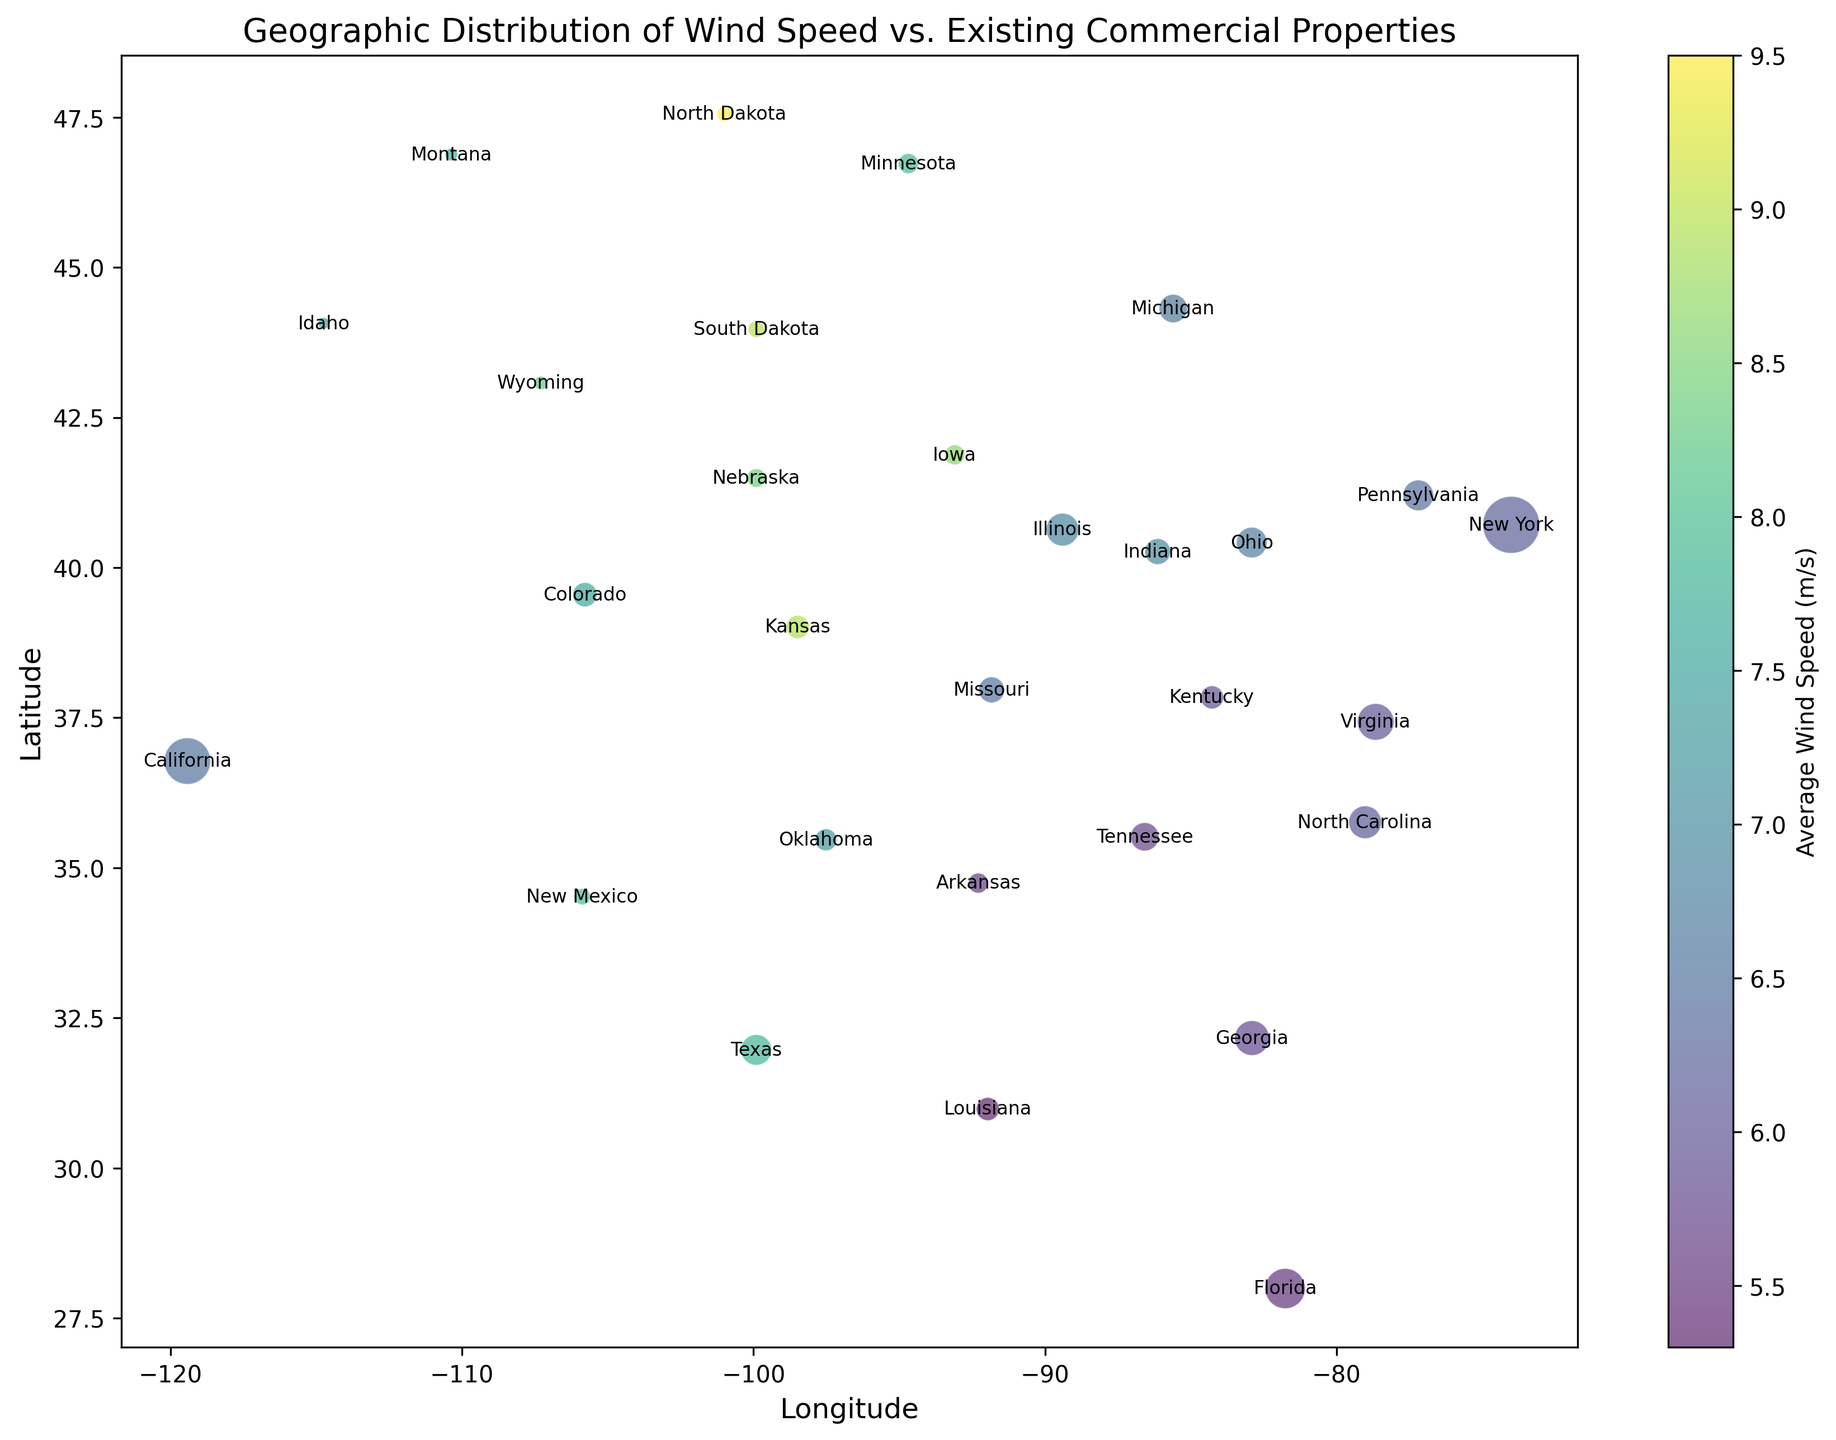Which location has the highest average wind speed? By looking at the color and name annotations in the figure, the location with the darkest shade indicating the highest wind speed is North Dakota.
Answer: North Dakota Which location has the largest number of commercial properties? The largest bubble on the plot represents New York, indicating it has the highest number of commercial properties.
Answer: New York What is the average wind speed of California and Florida combined? The average wind speed for California is 6.5 m/s and for Florida is 5.5 m/s. The combined average is (6.5 + 5.5) / 2 = 6.0 m/s.
Answer: 6.0 m/s Which has a greater average wind speed: Texas or Wyoming? By referring to the color shading, Texas has an average wind speed of 7.8 m/s while Wyoming has 8.3 m/s. Wyoming has a greater average wind speed.
Answer: Wyoming What is the difference in the number of commercial properties between Ohio and Indiana? According to the bubble size and annotations, Ohio has 350 properties and Indiana has 250 properties. The difference is 350 - 250 = 100 properties.
Answer: 100 properties Which two locations have the smallest number of commercial properties? The smallest bubbles in the chart are for Montana and Idaho, indicating they have the fewest commercial properties.
Answer: Montana and Idaho What is the total number of commercial properties in the locations with an average wind speed of 8.0 m/s or higher? Locations with wind speeds of 8.0 m/s or higher are Iowa, Kansas, Nebraska, South Dakota, North Dakota, New Mexico, and Wyoming. The total number is 150 (Iowa) + 200 (Kansas) + 130 (Nebraska) + 100 (S. Dakota) + 80 (N. Dakota) + 100 (New Mexico) + 70 (Wyoming) = 830 properties.
Answer: 830 properties Which location is nearest to New York in terms of latitude and longitude? Referring to the plot, the nearest bubbles to New York (which has the coordinates of 40.7128, -74.0059) are those for Pennsylvania (41.2033, -77.1945) and Ohio (40.4173, -82.9071). Pennsylvania is slightly closer based on visual proximity in the plot.
Answer: Pennsylvania 